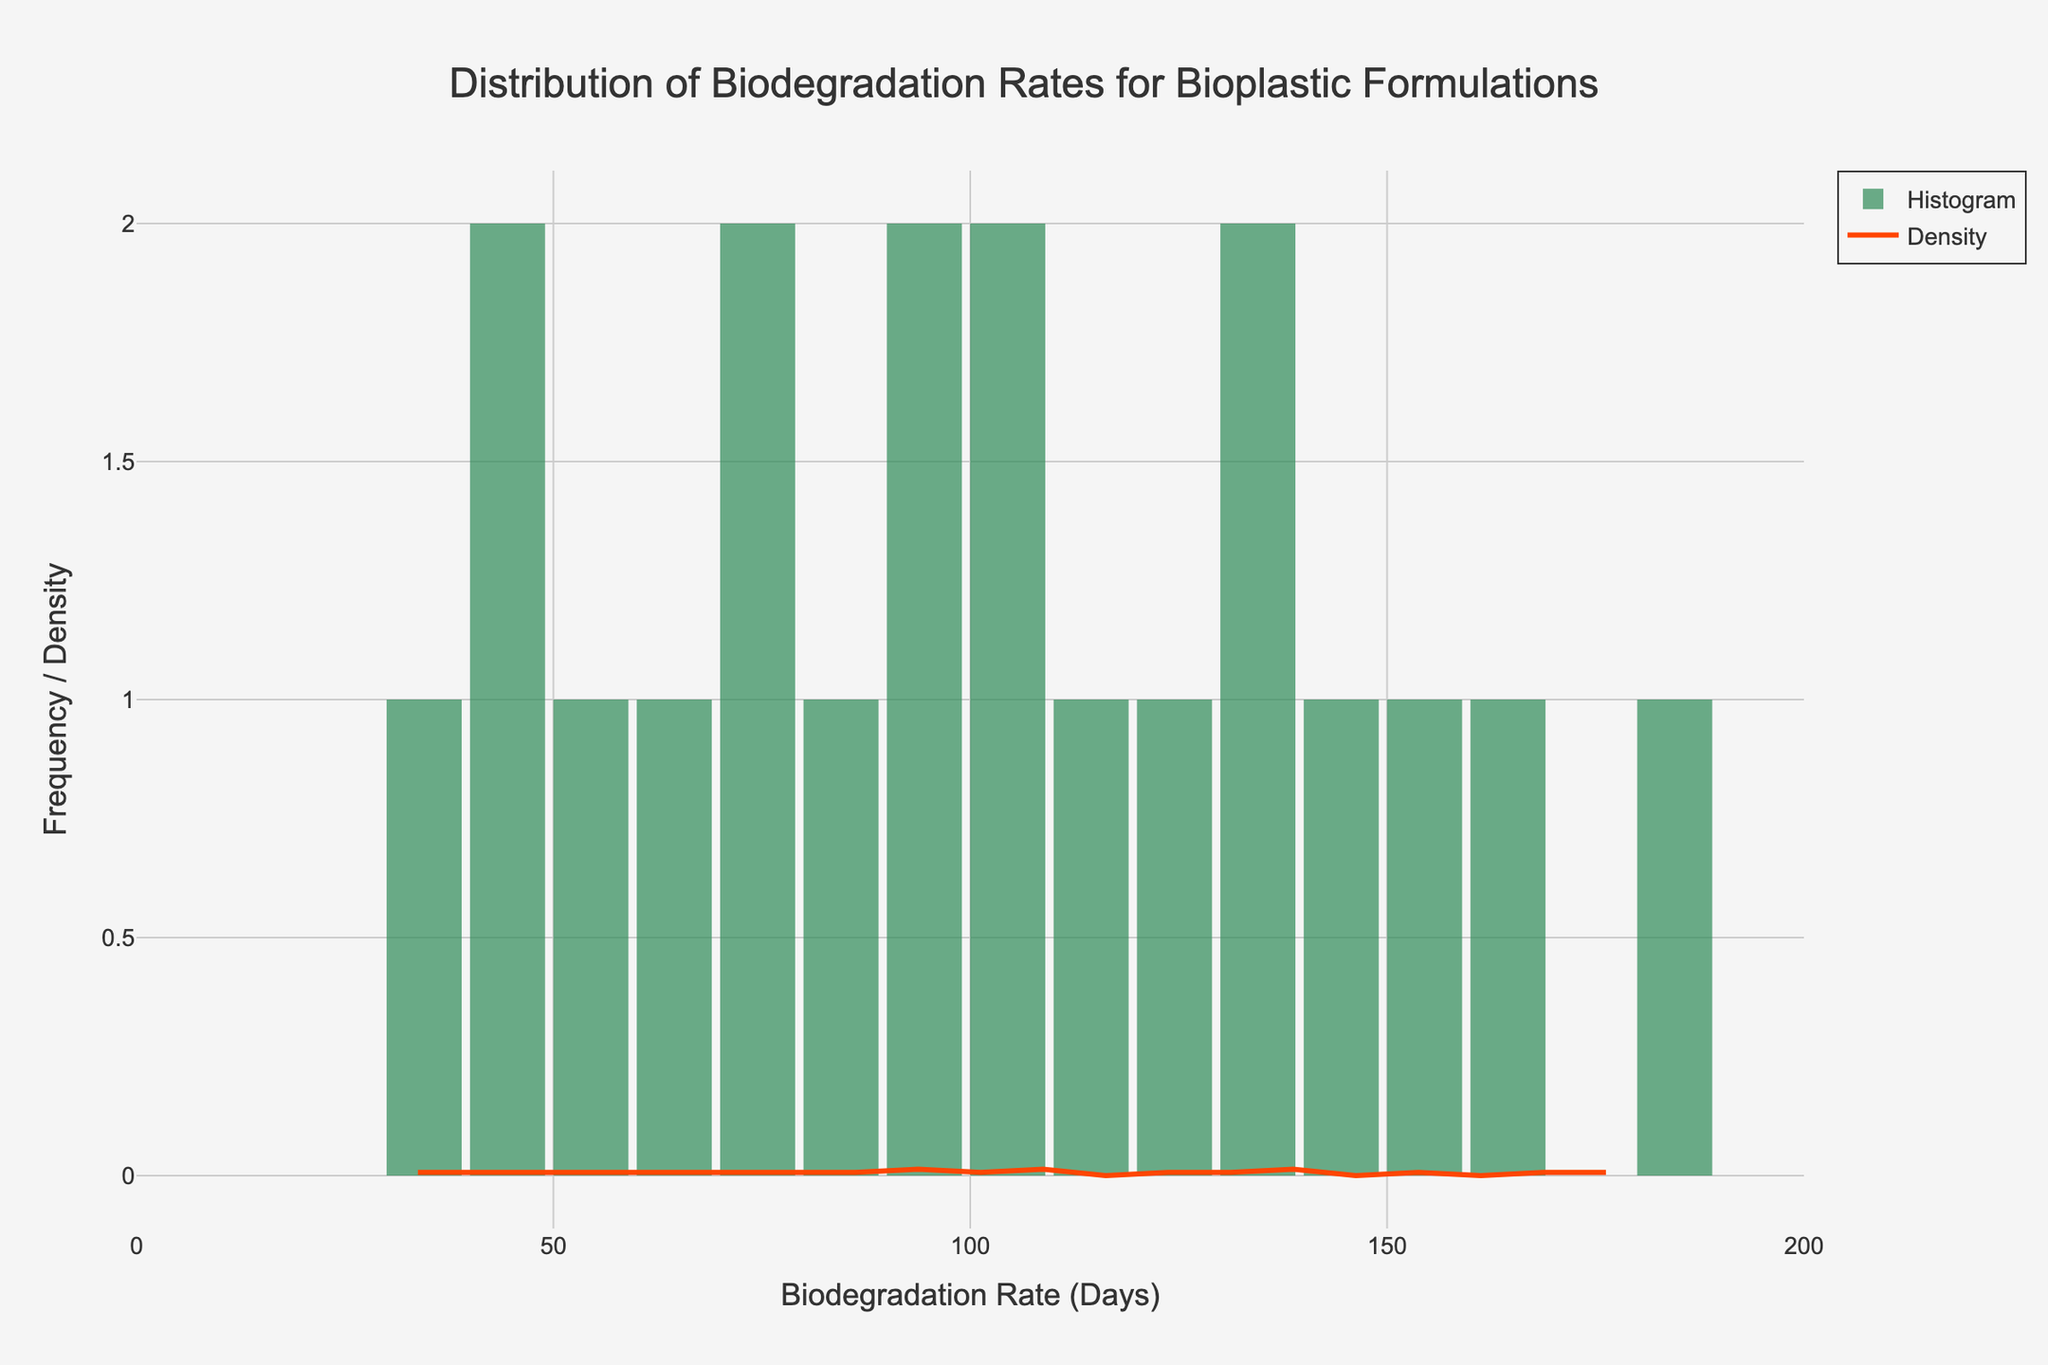What is the title of the histogram? The title is displayed prominently at the top of the figure. It states, "Distribution of Biodegradation Rates for Bioplastic Formulations".
Answer: Distribution of Biodegradation Rates for Bioplastic Formulations Which color represents the histogram bars? The color of the histogram bars can be identified by looking at the bars themselves. They are shaded in a green color.
Answer: Green What is shown on the x-axis? The x-axis represents the biodegradation rate in days, as indicated by the x-axis title "Biodegradation Rate (Days)".
Answer: Biodegradation Rate (Days) What is the range of biodegradation rates depicted in the histogram? The range of biodegradation rates can be determined by examining the span of the x-axis. They range from 0 to a bit above 180 days.
Answer: 0 to ~180 days What does the orange line in the plot represent? The orange line is a KDE (Kernel Density Estimate) curve, representing the estimated probability density function of the biodegradation rates.
Answer: KDE curve Which biodegradation rate appears most frequently in the data? By examining the histogram bars, the biodegradation rate with the highest bar around 90 days indicates it appears most frequently.
Answer: ~90 days How many data points are there with a biodegradation rate less than 50 days? Count the histogram bars falling under the range of 0 to 50 days. There are three bars in this region, corresponding to three data points: Chitosan-based Film (45), PVA/Starch Blend (30), and Alginate-based Film (40).
Answer: 3 What is the median biodegradation rate of the bioplastic formulations if visually estimated from the histogram? Visually estimate the median by identifying the central value when the rates are ordered. Given the spread of the data, the median falls roughly around the midpoint, near 95 days. This is a rough estimate based on the symmetry of the histogram.
Answer: ~95 days How does the frequency distribution of biodegradation rates compare between 60 and 120 days? The histogram bars from 60 to 120 days show that there are several tall bars, indicating a higher frequency of biodegradation rates in this range compared to other ranges.
Answer: Higher frequency Is there any biodegradation rate that is significantly different from others in terms of frequency? The biodegradation rate around 90 days shows a significantly higher frequency compared to other ranges. This can be observed from the tallest histogram bar in that range.
Answer: Yes, around 90 days 